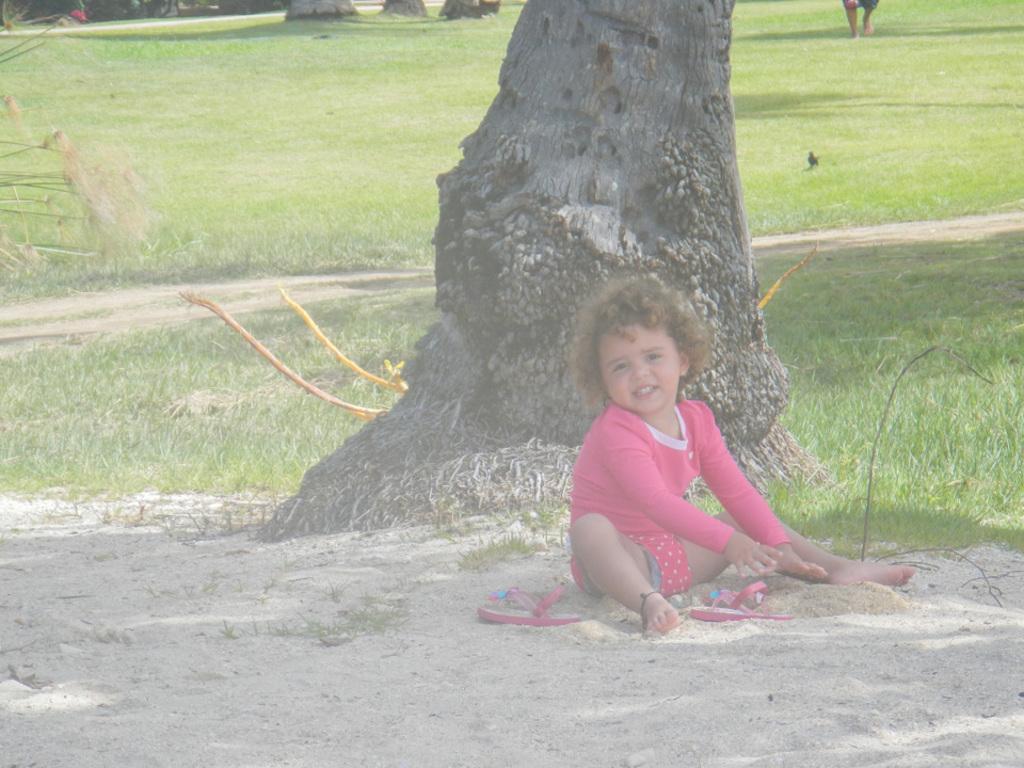Can you describe this image briefly? In this picture I can observe a girl sitting on the land and playing in the sand. Behind her there is a tree. The girl is wearing pink color dress. In the background I can observe some grass on the ground. 